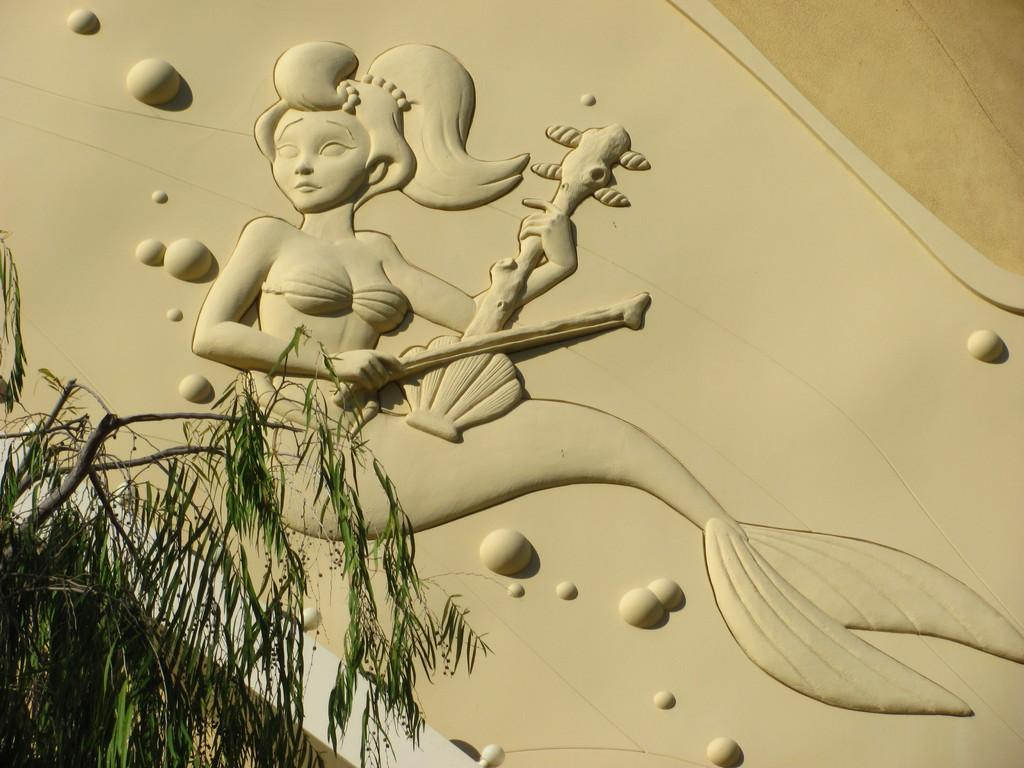What is depicted in the art that is displayed on the wall in the image? There is an art of a mermaid in the image. What is the mermaid doing in the art? The mermaid is playing a musical instrument in the art. Where is the art displayed in the image? The art is displayed on a wall. What natural element can be seen in the image? There is a tree visible in the image. Can you see a snake slithering up the tree in the image? There is no snake visible in the image; only a tree is present. What type of house is shown in the image? There is no house present in the image; it features an art of a mermaid displayed on a wall. 